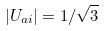<formula> <loc_0><loc_0><loc_500><loc_500>| U _ { a i } | = 1 / \sqrt { 3 }</formula> 